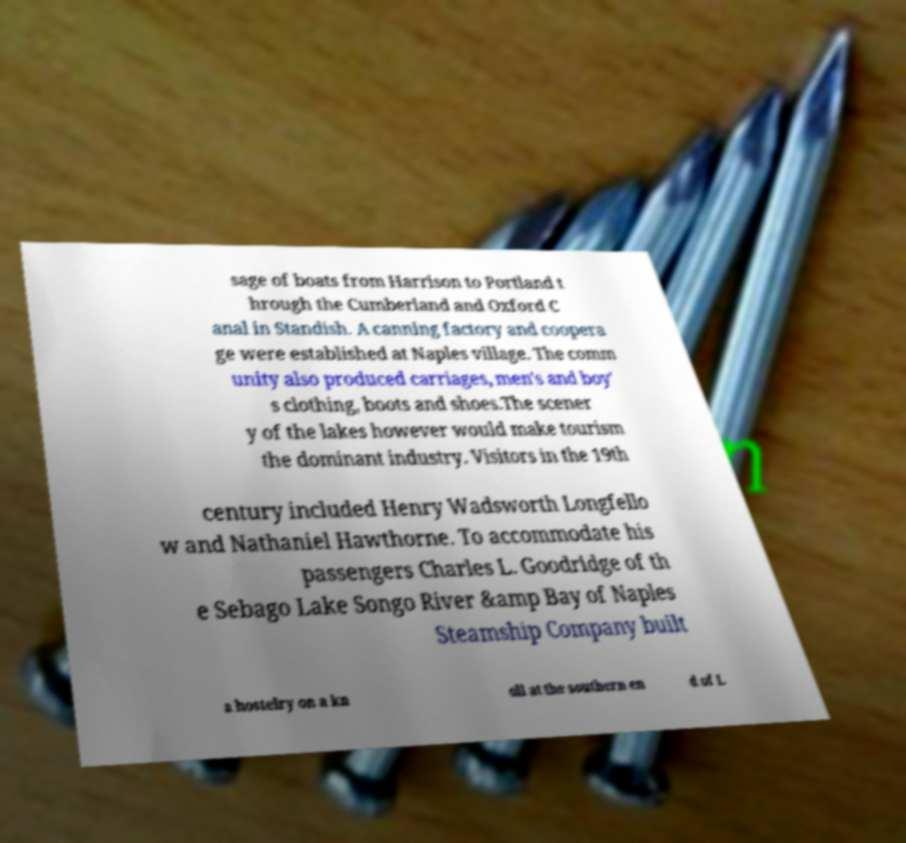What messages or text are displayed in this image? I need them in a readable, typed format. sage of boats from Harrison to Portland t hrough the Cumberland and Oxford C anal in Standish. A canning factory and coopera ge were established at Naples village. The comm unity also produced carriages, men's and boy' s clothing, boots and shoes.The scener y of the lakes however would make tourism the dominant industry. Visitors in the 19th century included Henry Wadsworth Longfello w and Nathaniel Hawthorne. To accommodate his passengers Charles L. Goodridge of th e Sebago Lake Songo River &amp Bay of Naples Steamship Company built a hostelry on a kn oll at the southern en d of L 